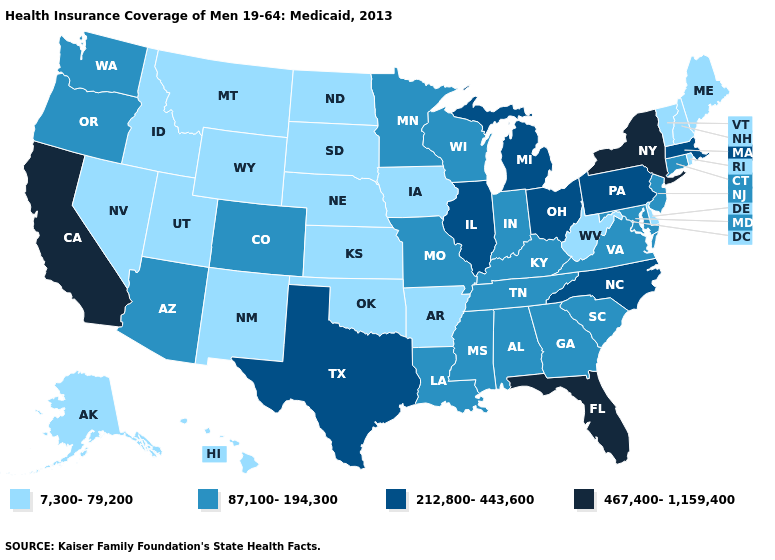What is the highest value in states that border Washington?
Write a very short answer. 87,100-194,300. Among the states that border Wisconsin , does Illinois have the highest value?
Short answer required. Yes. Does the first symbol in the legend represent the smallest category?
Quick response, please. Yes. What is the value of Wyoming?
Quick response, please. 7,300-79,200. What is the value of Alabama?
Concise answer only. 87,100-194,300. Which states have the lowest value in the USA?
Quick response, please. Alaska, Arkansas, Delaware, Hawaii, Idaho, Iowa, Kansas, Maine, Montana, Nebraska, Nevada, New Hampshire, New Mexico, North Dakota, Oklahoma, Rhode Island, South Dakota, Utah, Vermont, West Virginia, Wyoming. Name the states that have a value in the range 212,800-443,600?
Keep it brief. Illinois, Massachusetts, Michigan, North Carolina, Ohio, Pennsylvania, Texas. Name the states that have a value in the range 7,300-79,200?
Be succinct. Alaska, Arkansas, Delaware, Hawaii, Idaho, Iowa, Kansas, Maine, Montana, Nebraska, Nevada, New Hampshire, New Mexico, North Dakota, Oklahoma, Rhode Island, South Dakota, Utah, Vermont, West Virginia, Wyoming. Does New Jersey have the lowest value in the Northeast?
Give a very brief answer. No. Does Minnesota have a lower value than North Dakota?
Quick response, please. No. Name the states that have a value in the range 212,800-443,600?
Be succinct. Illinois, Massachusetts, Michigan, North Carolina, Ohio, Pennsylvania, Texas. What is the value of Texas?
Give a very brief answer. 212,800-443,600. What is the highest value in the South ?
Short answer required. 467,400-1,159,400. Does Maine have the highest value in the Northeast?
Quick response, please. No. What is the lowest value in states that border Kansas?
Quick response, please. 7,300-79,200. 